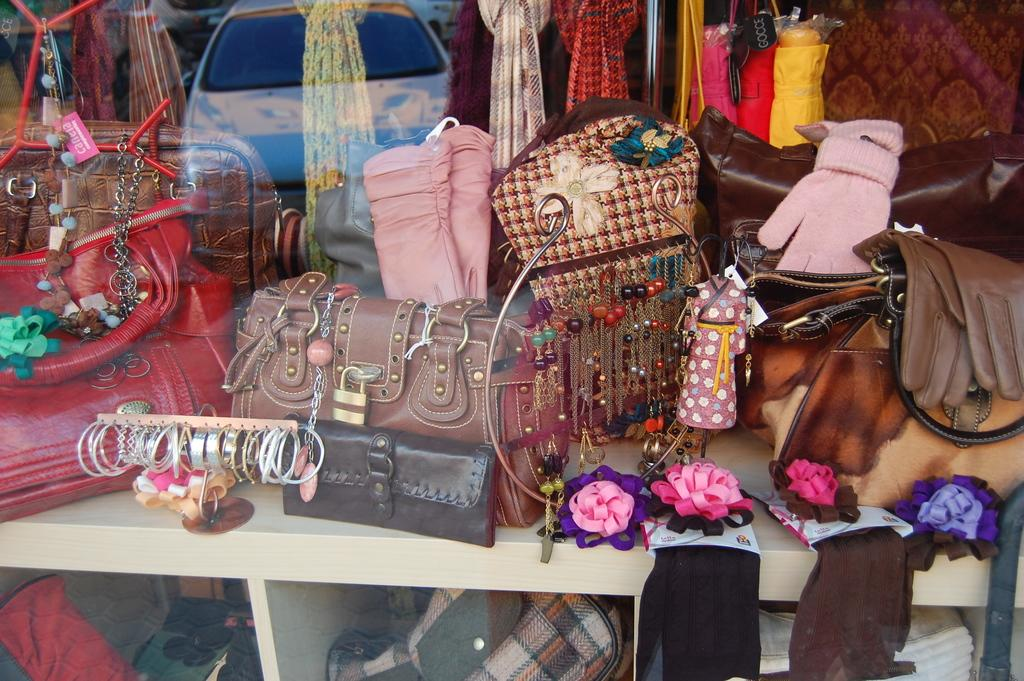What type of items can be seen in the image? There are handbags, gloves, and bangles in the image. Where are these items located? They are on the desk and placed in a shelf in the bottom of the image. What other accessories can be seen in the image? There are accessories on the desk in the image. What type of canvas is being used to paint the distance in the image? There is no canvas or painting of a distance present in the image. 